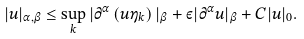Convert formula to latex. <formula><loc_0><loc_0><loc_500><loc_500>| u | _ { \alpha , \beta } \leq \sup _ { k } | \partial ^ { \alpha } \left ( u \eta _ { k } \right ) | _ { \beta } + \varepsilon | \partial ^ { \alpha } u | _ { \beta } + C | u | _ { 0 } .</formula> 